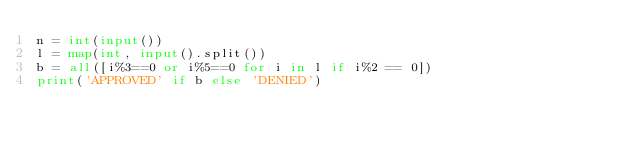Convert code to text. <code><loc_0><loc_0><loc_500><loc_500><_Python_>n = int(input())
l = map(int, input().split())
b = all([i%3==0 or i%5==0 for i in l if i%2 == 0])
print('APPROVED' if b else 'DENIED')
</code> 